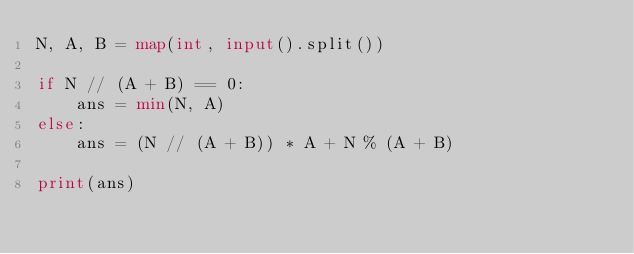<code> <loc_0><loc_0><loc_500><loc_500><_Python_>N, A, B = map(int, input().split())

if N // (A + B) == 0:
    ans = min(N, A)
else:
    ans = (N // (A + B)) * A + N % (A + B)

print(ans)
</code> 